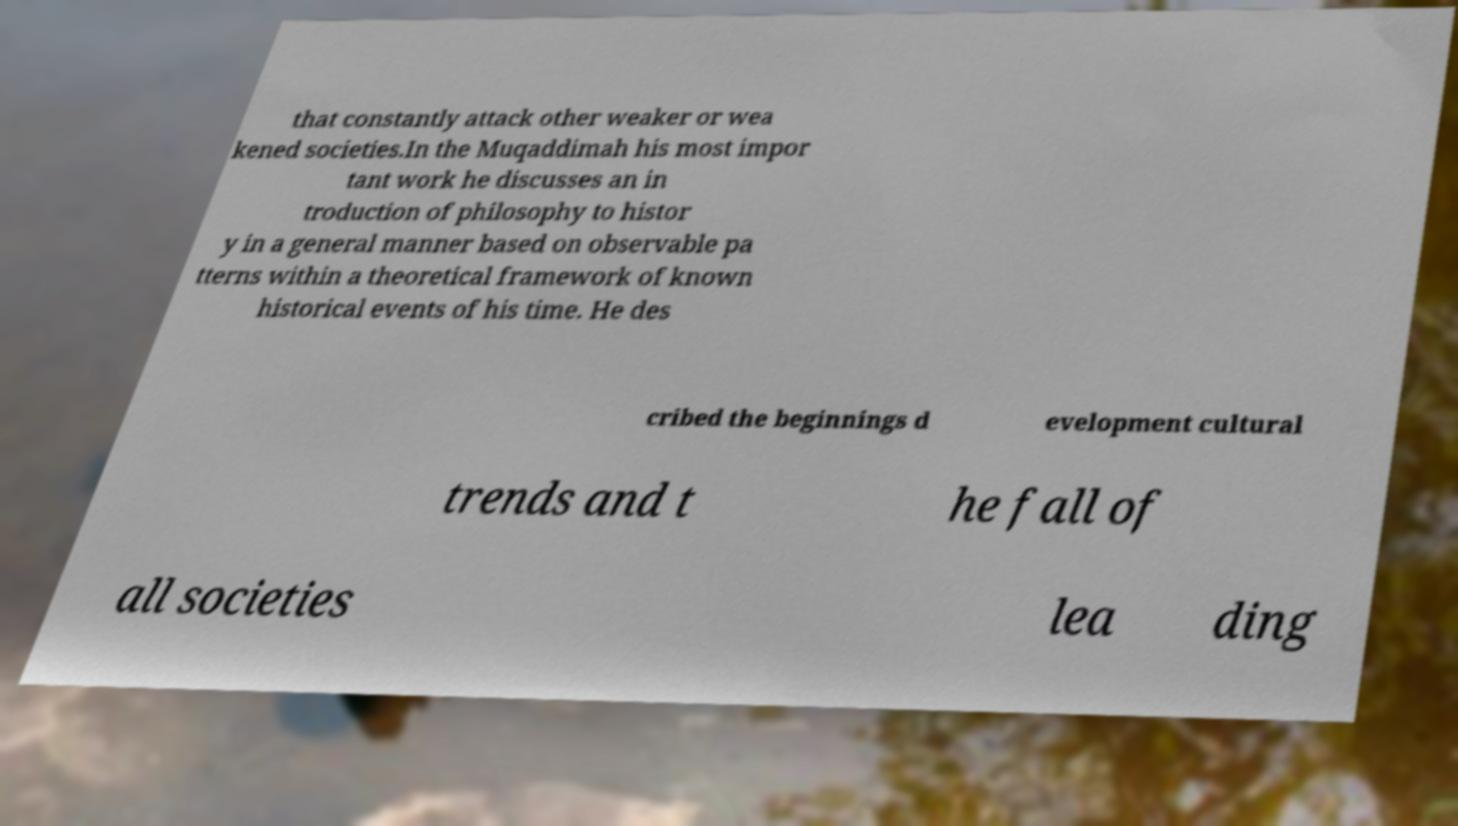What messages or text are displayed in this image? I need them in a readable, typed format. that constantly attack other weaker or wea kened societies.In the Muqaddimah his most impor tant work he discusses an in troduction of philosophy to histor y in a general manner based on observable pa tterns within a theoretical framework of known historical events of his time. He des cribed the beginnings d evelopment cultural trends and t he fall of all societies lea ding 